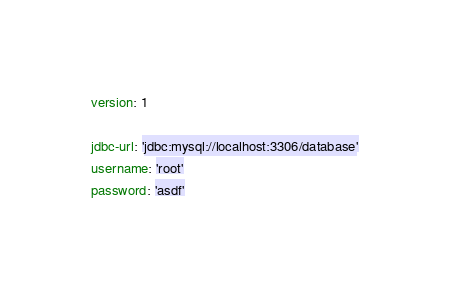Convert code to text. <code><loc_0><loc_0><loc_500><loc_500><_YAML_>version: 1

jdbc-url: 'jdbc:mysql://localhost:3306/database'
username: 'root'
password: 'asdf'</code> 